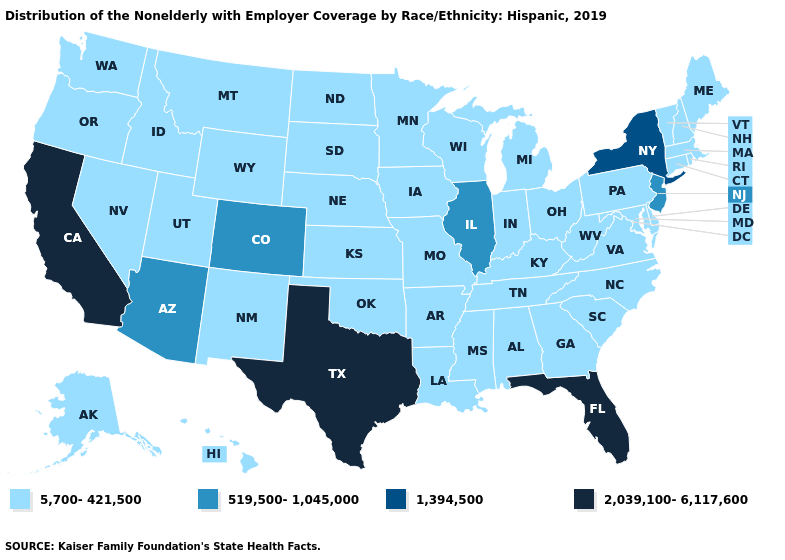What is the value of Rhode Island?
Quick response, please. 5,700-421,500. What is the highest value in the USA?
Be succinct. 2,039,100-6,117,600. How many symbols are there in the legend?
Write a very short answer. 4. Name the states that have a value in the range 1,394,500?
Keep it brief. New York. What is the value of Nebraska?
Answer briefly. 5,700-421,500. Which states have the highest value in the USA?
Keep it brief. California, Florida, Texas. Does Florida have the lowest value in the South?
Be succinct. No. Name the states that have a value in the range 519,500-1,045,000?
Be succinct. Arizona, Colorado, Illinois, New Jersey. Name the states that have a value in the range 1,394,500?
Give a very brief answer. New York. Which states hav the highest value in the West?
Keep it brief. California. Does New York have the lowest value in the Northeast?
Concise answer only. No. How many symbols are there in the legend?
Write a very short answer. 4. How many symbols are there in the legend?
Concise answer only. 4. Which states hav the highest value in the MidWest?
Give a very brief answer. Illinois. What is the lowest value in states that border Maryland?
Be succinct. 5,700-421,500. 